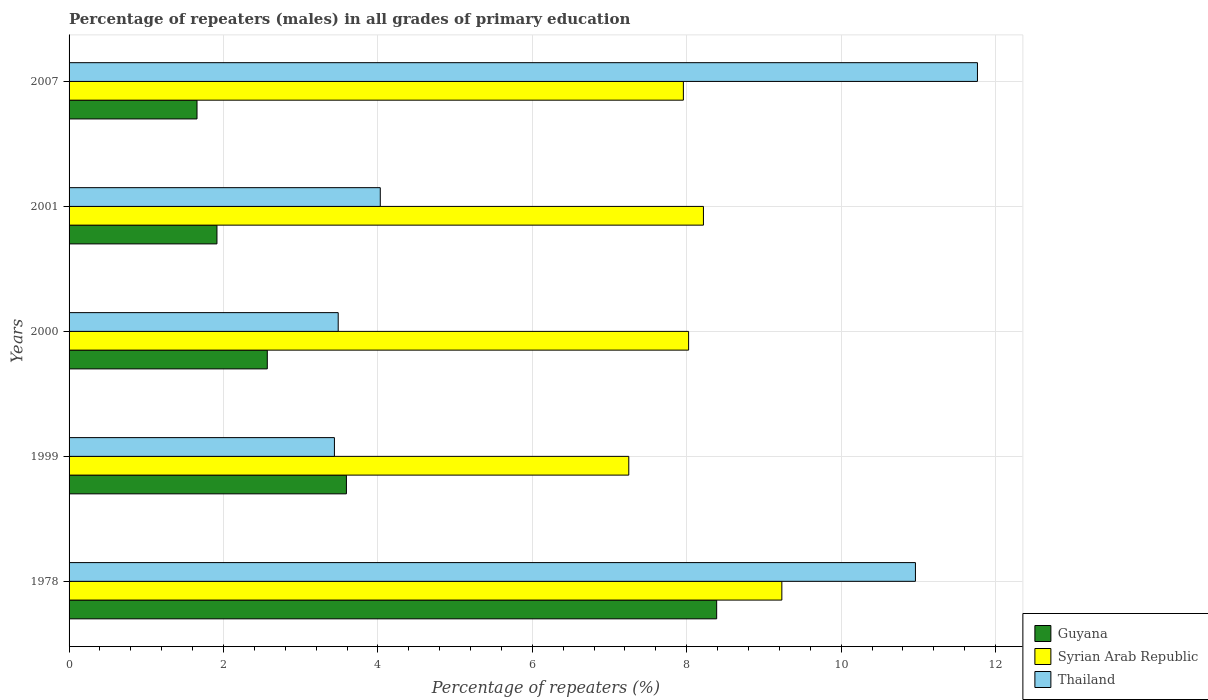How many groups of bars are there?
Your response must be concise. 5. How many bars are there on the 2nd tick from the bottom?
Provide a succinct answer. 3. What is the label of the 1st group of bars from the top?
Your answer should be compact. 2007. In how many cases, is the number of bars for a given year not equal to the number of legend labels?
Your response must be concise. 0. What is the percentage of repeaters (males) in Thailand in 2000?
Offer a terse response. 3.49. Across all years, what is the maximum percentage of repeaters (males) in Syrian Arab Republic?
Offer a terse response. 9.23. Across all years, what is the minimum percentage of repeaters (males) in Guyana?
Ensure brevity in your answer.  1.66. In which year was the percentage of repeaters (males) in Thailand maximum?
Offer a very short reply. 2007. What is the total percentage of repeaters (males) in Thailand in the graph?
Offer a very short reply. 33.68. What is the difference between the percentage of repeaters (males) in Thailand in 1978 and that in 2007?
Provide a short and direct response. -0.8. What is the difference between the percentage of repeaters (males) in Thailand in 2007 and the percentage of repeaters (males) in Guyana in 2001?
Offer a terse response. 9.85. What is the average percentage of repeaters (males) in Syrian Arab Republic per year?
Ensure brevity in your answer.  8.14. In the year 2007, what is the difference between the percentage of repeaters (males) in Guyana and percentage of repeaters (males) in Syrian Arab Republic?
Keep it short and to the point. -6.3. In how many years, is the percentage of repeaters (males) in Thailand greater than 2.4 %?
Provide a succinct answer. 5. What is the ratio of the percentage of repeaters (males) in Thailand in 1999 to that in 2001?
Make the answer very short. 0.85. Is the difference between the percentage of repeaters (males) in Guyana in 1999 and 2001 greater than the difference between the percentage of repeaters (males) in Syrian Arab Republic in 1999 and 2001?
Your answer should be compact. Yes. What is the difference between the highest and the second highest percentage of repeaters (males) in Thailand?
Offer a very short reply. 0.8. What is the difference between the highest and the lowest percentage of repeaters (males) in Syrian Arab Republic?
Provide a short and direct response. 1.98. What does the 3rd bar from the top in 1978 represents?
Your answer should be very brief. Guyana. What does the 2nd bar from the bottom in 2001 represents?
Your answer should be very brief. Syrian Arab Republic. Is it the case that in every year, the sum of the percentage of repeaters (males) in Thailand and percentage of repeaters (males) in Syrian Arab Republic is greater than the percentage of repeaters (males) in Guyana?
Your answer should be compact. Yes. How many bars are there?
Provide a succinct answer. 15. How many years are there in the graph?
Keep it short and to the point. 5. What is the difference between two consecutive major ticks on the X-axis?
Your response must be concise. 2. Are the values on the major ticks of X-axis written in scientific E-notation?
Ensure brevity in your answer.  No. Does the graph contain any zero values?
Provide a succinct answer. No. Does the graph contain grids?
Provide a short and direct response. Yes. What is the title of the graph?
Ensure brevity in your answer.  Percentage of repeaters (males) in all grades of primary education. What is the label or title of the X-axis?
Provide a succinct answer. Percentage of repeaters (%). What is the Percentage of repeaters (%) of Guyana in 1978?
Offer a very short reply. 8.39. What is the Percentage of repeaters (%) of Syrian Arab Republic in 1978?
Your response must be concise. 9.23. What is the Percentage of repeaters (%) of Thailand in 1978?
Your answer should be very brief. 10.96. What is the Percentage of repeaters (%) of Guyana in 1999?
Provide a succinct answer. 3.59. What is the Percentage of repeaters (%) in Syrian Arab Republic in 1999?
Keep it short and to the point. 7.25. What is the Percentage of repeaters (%) of Thailand in 1999?
Ensure brevity in your answer.  3.44. What is the Percentage of repeaters (%) in Guyana in 2000?
Ensure brevity in your answer.  2.57. What is the Percentage of repeaters (%) of Syrian Arab Republic in 2000?
Your response must be concise. 8.02. What is the Percentage of repeaters (%) in Thailand in 2000?
Give a very brief answer. 3.49. What is the Percentage of repeaters (%) of Guyana in 2001?
Your answer should be compact. 1.92. What is the Percentage of repeaters (%) of Syrian Arab Republic in 2001?
Your answer should be very brief. 8.22. What is the Percentage of repeaters (%) of Thailand in 2001?
Provide a succinct answer. 4.03. What is the Percentage of repeaters (%) in Guyana in 2007?
Your answer should be very brief. 1.66. What is the Percentage of repeaters (%) of Syrian Arab Republic in 2007?
Make the answer very short. 7.96. What is the Percentage of repeaters (%) of Thailand in 2007?
Keep it short and to the point. 11.77. Across all years, what is the maximum Percentage of repeaters (%) in Guyana?
Provide a short and direct response. 8.39. Across all years, what is the maximum Percentage of repeaters (%) of Syrian Arab Republic?
Your answer should be compact. 9.23. Across all years, what is the maximum Percentage of repeaters (%) in Thailand?
Your response must be concise. 11.77. Across all years, what is the minimum Percentage of repeaters (%) in Guyana?
Keep it short and to the point. 1.66. Across all years, what is the minimum Percentage of repeaters (%) of Syrian Arab Republic?
Offer a very short reply. 7.25. Across all years, what is the minimum Percentage of repeaters (%) in Thailand?
Your answer should be very brief. 3.44. What is the total Percentage of repeaters (%) of Guyana in the graph?
Offer a very short reply. 18.12. What is the total Percentage of repeaters (%) in Syrian Arab Republic in the graph?
Ensure brevity in your answer.  40.68. What is the total Percentage of repeaters (%) of Thailand in the graph?
Keep it short and to the point. 33.68. What is the difference between the Percentage of repeaters (%) of Guyana in 1978 and that in 1999?
Keep it short and to the point. 4.8. What is the difference between the Percentage of repeaters (%) of Syrian Arab Republic in 1978 and that in 1999?
Your answer should be very brief. 1.98. What is the difference between the Percentage of repeaters (%) in Thailand in 1978 and that in 1999?
Offer a very short reply. 7.53. What is the difference between the Percentage of repeaters (%) in Guyana in 1978 and that in 2000?
Offer a terse response. 5.82. What is the difference between the Percentage of repeaters (%) of Syrian Arab Republic in 1978 and that in 2000?
Provide a short and direct response. 1.21. What is the difference between the Percentage of repeaters (%) in Thailand in 1978 and that in 2000?
Ensure brevity in your answer.  7.48. What is the difference between the Percentage of repeaters (%) of Guyana in 1978 and that in 2001?
Your answer should be compact. 6.47. What is the difference between the Percentage of repeaters (%) in Syrian Arab Republic in 1978 and that in 2001?
Your answer should be compact. 1.02. What is the difference between the Percentage of repeaters (%) of Thailand in 1978 and that in 2001?
Keep it short and to the point. 6.93. What is the difference between the Percentage of repeaters (%) in Guyana in 1978 and that in 2007?
Provide a succinct answer. 6.73. What is the difference between the Percentage of repeaters (%) in Syrian Arab Republic in 1978 and that in 2007?
Provide a short and direct response. 1.28. What is the difference between the Percentage of repeaters (%) of Thailand in 1978 and that in 2007?
Ensure brevity in your answer.  -0.8. What is the difference between the Percentage of repeaters (%) of Syrian Arab Republic in 1999 and that in 2000?
Your response must be concise. -0.77. What is the difference between the Percentage of repeaters (%) in Thailand in 1999 and that in 2000?
Your response must be concise. -0.05. What is the difference between the Percentage of repeaters (%) in Guyana in 1999 and that in 2001?
Give a very brief answer. 1.68. What is the difference between the Percentage of repeaters (%) in Syrian Arab Republic in 1999 and that in 2001?
Provide a succinct answer. -0.97. What is the difference between the Percentage of repeaters (%) in Thailand in 1999 and that in 2001?
Keep it short and to the point. -0.59. What is the difference between the Percentage of repeaters (%) in Guyana in 1999 and that in 2007?
Provide a short and direct response. 1.94. What is the difference between the Percentage of repeaters (%) in Syrian Arab Republic in 1999 and that in 2007?
Give a very brief answer. -0.71. What is the difference between the Percentage of repeaters (%) of Thailand in 1999 and that in 2007?
Offer a very short reply. -8.33. What is the difference between the Percentage of repeaters (%) in Guyana in 2000 and that in 2001?
Your answer should be very brief. 0.65. What is the difference between the Percentage of repeaters (%) in Syrian Arab Republic in 2000 and that in 2001?
Keep it short and to the point. -0.19. What is the difference between the Percentage of repeaters (%) of Thailand in 2000 and that in 2001?
Provide a succinct answer. -0.55. What is the difference between the Percentage of repeaters (%) in Guyana in 2000 and that in 2007?
Offer a terse response. 0.91. What is the difference between the Percentage of repeaters (%) of Syrian Arab Republic in 2000 and that in 2007?
Your answer should be very brief. 0.07. What is the difference between the Percentage of repeaters (%) in Thailand in 2000 and that in 2007?
Offer a terse response. -8.28. What is the difference between the Percentage of repeaters (%) in Guyana in 2001 and that in 2007?
Your answer should be compact. 0.26. What is the difference between the Percentage of repeaters (%) of Syrian Arab Republic in 2001 and that in 2007?
Provide a short and direct response. 0.26. What is the difference between the Percentage of repeaters (%) in Thailand in 2001 and that in 2007?
Your answer should be compact. -7.73. What is the difference between the Percentage of repeaters (%) of Guyana in 1978 and the Percentage of repeaters (%) of Syrian Arab Republic in 1999?
Offer a very short reply. 1.14. What is the difference between the Percentage of repeaters (%) in Guyana in 1978 and the Percentage of repeaters (%) in Thailand in 1999?
Your answer should be very brief. 4.95. What is the difference between the Percentage of repeaters (%) of Syrian Arab Republic in 1978 and the Percentage of repeaters (%) of Thailand in 1999?
Provide a short and direct response. 5.8. What is the difference between the Percentage of repeaters (%) in Guyana in 1978 and the Percentage of repeaters (%) in Syrian Arab Republic in 2000?
Give a very brief answer. 0.36. What is the difference between the Percentage of repeaters (%) in Guyana in 1978 and the Percentage of repeaters (%) in Thailand in 2000?
Provide a short and direct response. 4.9. What is the difference between the Percentage of repeaters (%) of Syrian Arab Republic in 1978 and the Percentage of repeaters (%) of Thailand in 2000?
Offer a very short reply. 5.75. What is the difference between the Percentage of repeaters (%) in Guyana in 1978 and the Percentage of repeaters (%) in Syrian Arab Republic in 2001?
Ensure brevity in your answer.  0.17. What is the difference between the Percentage of repeaters (%) of Guyana in 1978 and the Percentage of repeaters (%) of Thailand in 2001?
Make the answer very short. 4.36. What is the difference between the Percentage of repeaters (%) in Syrian Arab Republic in 1978 and the Percentage of repeaters (%) in Thailand in 2001?
Your answer should be very brief. 5.2. What is the difference between the Percentage of repeaters (%) of Guyana in 1978 and the Percentage of repeaters (%) of Syrian Arab Republic in 2007?
Keep it short and to the point. 0.43. What is the difference between the Percentage of repeaters (%) in Guyana in 1978 and the Percentage of repeaters (%) in Thailand in 2007?
Your answer should be compact. -3.38. What is the difference between the Percentage of repeaters (%) of Syrian Arab Republic in 1978 and the Percentage of repeaters (%) of Thailand in 2007?
Offer a terse response. -2.53. What is the difference between the Percentage of repeaters (%) of Guyana in 1999 and the Percentage of repeaters (%) of Syrian Arab Republic in 2000?
Your answer should be compact. -4.43. What is the difference between the Percentage of repeaters (%) in Guyana in 1999 and the Percentage of repeaters (%) in Thailand in 2000?
Offer a very short reply. 0.11. What is the difference between the Percentage of repeaters (%) in Syrian Arab Republic in 1999 and the Percentage of repeaters (%) in Thailand in 2000?
Provide a succinct answer. 3.76. What is the difference between the Percentage of repeaters (%) in Guyana in 1999 and the Percentage of repeaters (%) in Syrian Arab Republic in 2001?
Provide a succinct answer. -4.62. What is the difference between the Percentage of repeaters (%) in Guyana in 1999 and the Percentage of repeaters (%) in Thailand in 2001?
Offer a very short reply. -0.44. What is the difference between the Percentage of repeaters (%) in Syrian Arab Republic in 1999 and the Percentage of repeaters (%) in Thailand in 2001?
Give a very brief answer. 3.22. What is the difference between the Percentage of repeaters (%) in Guyana in 1999 and the Percentage of repeaters (%) in Syrian Arab Republic in 2007?
Ensure brevity in your answer.  -4.36. What is the difference between the Percentage of repeaters (%) in Guyana in 1999 and the Percentage of repeaters (%) in Thailand in 2007?
Offer a terse response. -8.17. What is the difference between the Percentage of repeaters (%) in Syrian Arab Republic in 1999 and the Percentage of repeaters (%) in Thailand in 2007?
Keep it short and to the point. -4.52. What is the difference between the Percentage of repeaters (%) of Guyana in 2000 and the Percentage of repeaters (%) of Syrian Arab Republic in 2001?
Keep it short and to the point. -5.65. What is the difference between the Percentage of repeaters (%) of Guyana in 2000 and the Percentage of repeaters (%) of Thailand in 2001?
Provide a succinct answer. -1.46. What is the difference between the Percentage of repeaters (%) of Syrian Arab Republic in 2000 and the Percentage of repeaters (%) of Thailand in 2001?
Provide a succinct answer. 3.99. What is the difference between the Percentage of repeaters (%) of Guyana in 2000 and the Percentage of repeaters (%) of Syrian Arab Republic in 2007?
Provide a short and direct response. -5.39. What is the difference between the Percentage of repeaters (%) of Guyana in 2000 and the Percentage of repeaters (%) of Thailand in 2007?
Offer a terse response. -9.2. What is the difference between the Percentage of repeaters (%) of Syrian Arab Republic in 2000 and the Percentage of repeaters (%) of Thailand in 2007?
Provide a succinct answer. -3.74. What is the difference between the Percentage of repeaters (%) in Guyana in 2001 and the Percentage of repeaters (%) in Syrian Arab Republic in 2007?
Your answer should be very brief. -6.04. What is the difference between the Percentage of repeaters (%) of Guyana in 2001 and the Percentage of repeaters (%) of Thailand in 2007?
Provide a succinct answer. -9.85. What is the difference between the Percentage of repeaters (%) in Syrian Arab Republic in 2001 and the Percentage of repeaters (%) in Thailand in 2007?
Offer a very short reply. -3.55. What is the average Percentage of repeaters (%) of Guyana per year?
Your answer should be very brief. 3.62. What is the average Percentage of repeaters (%) of Syrian Arab Republic per year?
Offer a very short reply. 8.14. What is the average Percentage of repeaters (%) of Thailand per year?
Make the answer very short. 6.74. In the year 1978, what is the difference between the Percentage of repeaters (%) of Guyana and Percentage of repeaters (%) of Syrian Arab Republic?
Your answer should be compact. -0.84. In the year 1978, what is the difference between the Percentage of repeaters (%) in Guyana and Percentage of repeaters (%) in Thailand?
Your response must be concise. -2.57. In the year 1978, what is the difference between the Percentage of repeaters (%) in Syrian Arab Republic and Percentage of repeaters (%) in Thailand?
Your answer should be very brief. -1.73. In the year 1999, what is the difference between the Percentage of repeaters (%) of Guyana and Percentage of repeaters (%) of Syrian Arab Republic?
Your answer should be compact. -3.66. In the year 1999, what is the difference between the Percentage of repeaters (%) in Guyana and Percentage of repeaters (%) in Thailand?
Your answer should be very brief. 0.16. In the year 1999, what is the difference between the Percentage of repeaters (%) in Syrian Arab Republic and Percentage of repeaters (%) in Thailand?
Give a very brief answer. 3.81. In the year 2000, what is the difference between the Percentage of repeaters (%) of Guyana and Percentage of repeaters (%) of Syrian Arab Republic?
Your answer should be compact. -5.46. In the year 2000, what is the difference between the Percentage of repeaters (%) of Guyana and Percentage of repeaters (%) of Thailand?
Ensure brevity in your answer.  -0.92. In the year 2000, what is the difference between the Percentage of repeaters (%) in Syrian Arab Republic and Percentage of repeaters (%) in Thailand?
Provide a short and direct response. 4.54. In the year 2001, what is the difference between the Percentage of repeaters (%) of Guyana and Percentage of repeaters (%) of Syrian Arab Republic?
Provide a short and direct response. -6.3. In the year 2001, what is the difference between the Percentage of repeaters (%) of Guyana and Percentage of repeaters (%) of Thailand?
Offer a very short reply. -2.12. In the year 2001, what is the difference between the Percentage of repeaters (%) in Syrian Arab Republic and Percentage of repeaters (%) in Thailand?
Ensure brevity in your answer.  4.19. In the year 2007, what is the difference between the Percentage of repeaters (%) in Guyana and Percentage of repeaters (%) in Syrian Arab Republic?
Your answer should be very brief. -6.3. In the year 2007, what is the difference between the Percentage of repeaters (%) in Guyana and Percentage of repeaters (%) in Thailand?
Ensure brevity in your answer.  -10.11. In the year 2007, what is the difference between the Percentage of repeaters (%) of Syrian Arab Republic and Percentage of repeaters (%) of Thailand?
Keep it short and to the point. -3.81. What is the ratio of the Percentage of repeaters (%) in Guyana in 1978 to that in 1999?
Keep it short and to the point. 2.33. What is the ratio of the Percentage of repeaters (%) of Syrian Arab Republic in 1978 to that in 1999?
Your answer should be very brief. 1.27. What is the ratio of the Percentage of repeaters (%) of Thailand in 1978 to that in 1999?
Provide a succinct answer. 3.19. What is the ratio of the Percentage of repeaters (%) of Guyana in 1978 to that in 2000?
Offer a terse response. 3.27. What is the ratio of the Percentage of repeaters (%) in Syrian Arab Republic in 1978 to that in 2000?
Give a very brief answer. 1.15. What is the ratio of the Percentage of repeaters (%) in Thailand in 1978 to that in 2000?
Make the answer very short. 3.14. What is the ratio of the Percentage of repeaters (%) of Guyana in 1978 to that in 2001?
Your answer should be very brief. 4.38. What is the ratio of the Percentage of repeaters (%) of Syrian Arab Republic in 1978 to that in 2001?
Your answer should be very brief. 1.12. What is the ratio of the Percentage of repeaters (%) in Thailand in 1978 to that in 2001?
Make the answer very short. 2.72. What is the ratio of the Percentage of repeaters (%) of Guyana in 1978 to that in 2007?
Your response must be concise. 5.06. What is the ratio of the Percentage of repeaters (%) of Syrian Arab Republic in 1978 to that in 2007?
Keep it short and to the point. 1.16. What is the ratio of the Percentage of repeaters (%) of Thailand in 1978 to that in 2007?
Offer a very short reply. 0.93. What is the ratio of the Percentage of repeaters (%) in Guyana in 1999 to that in 2000?
Your answer should be compact. 1.4. What is the ratio of the Percentage of repeaters (%) of Syrian Arab Republic in 1999 to that in 2000?
Ensure brevity in your answer.  0.9. What is the ratio of the Percentage of repeaters (%) in Thailand in 1999 to that in 2000?
Ensure brevity in your answer.  0.99. What is the ratio of the Percentage of repeaters (%) of Guyana in 1999 to that in 2001?
Your answer should be very brief. 1.88. What is the ratio of the Percentage of repeaters (%) in Syrian Arab Republic in 1999 to that in 2001?
Ensure brevity in your answer.  0.88. What is the ratio of the Percentage of repeaters (%) in Thailand in 1999 to that in 2001?
Give a very brief answer. 0.85. What is the ratio of the Percentage of repeaters (%) in Guyana in 1999 to that in 2007?
Your answer should be compact. 2.17. What is the ratio of the Percentage of repeaters (%) of Syrian Arab Republic in 1999 to that in 2007?
Provide a short and direct response. 0.91. What is the ratio of the Percentage of repeaters (%) in Thailand in 1999 to that in 2007?
Ensure brevity in your answer.  0.29. What is the ratio of the Percentage of repeaters (%) of Guyana in 2000 to that in 2001?
Your response must be concise. 1.34. What is the ratio of the Percentage of repeaters (%) of Syrian Arab Republic in 2000 to that in 2001?
Your response must be concise. 0.98. What is the ratio of the Percentage of repeaters (%) in Thailand in 2000 to that in 2001?
Make the answer very short. 0.86. What is the ratio of the Percentage of repeaters (%) of Guyana in 2000 to that in 2007?
Offer a terse response. 1.55. What is the ratio of the Percentage of repeaters (%) in Syrian Arab Republic in 2000 to that in 2007?
Ensure brevity in your answer.  1.01. What is the ratio of the Percentage of repeaters (%) in Thailand in 2000 to that in 2007?
Make the answer very short. 0.3. What is the ratio of the Percentage of repeaters (%) in Guyana in 2001 to that in 2007?
Keep it short and to the point. 1.16. What is the ratio of the Percentage of repeaters (%) in Syrian Arab Republic in 2001 to that in 2007?
Make the answer very short. 1.03. What is the ratio of the Percentage of repeaters (%) in Thailand in 2001 to that in 2007?
Your answer should be very brief. 0.34. What is the difference between the highest and the second highest Percentage of repeaters (%) in Guyana?
Keep it short and to the point. 4.8. What is the difference between the highest and the second highest Percentage of repeaters (%) in Syrian Arab Republic?
Offer a terse response. 1.02. What is the difference between the highest and the second highest Percentage of repeaters (%) of Thailand?
Provide a short and direct response. 0.8. What is the difference between the highest and the lowest Percentage of repeaters (%) of Guyana?
Offer a terse response. 6.73. What is the difference between the highest and the lowest Percentage of repeaters (%) in Syrian Arab Republic?
Your answer should be compact. 1.98. What is the difference between the highest and the lowest Percentage of repeaters (%) of Thailand?
Your response must be concise. 8.33. 